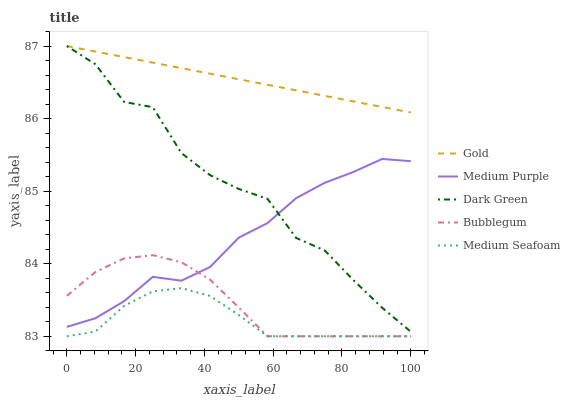Does Medium Seafoam have the minimum area under the curve?
Answer yes or no. Yes. Does Gold have the maximum area under the curve?
Answer yes or no. Yes. Does Bubblegum have the minimum area under the curve?
Answer yes or no. No. Does Bubblegum have the maximum area under the curve?
Answer yes or no. No. Is Gold the smoothest?
Answer yes or no. Yes. Is Dark Green the roughest?
Answer yes or no. Yes. Is Medium Seafoam the smoothest?
Answer yes or no. No. Is Medium Seafoam the roughest?
Answer yes or no. No. Does Medium Seafoam have the lowest value?
Answer yes or no. Yes. Does Gold have the lowest value?
Answer yes or no. No. Does Dark Green have the highest value?
Answer yes or no. Yes. Does Bubblegum have the highest value?
Answer yes or no. No. Is Medium Seafoam less than Medium Purple?
Answer yes or no. Yes. Is Gold greater than Medium Seafoam?
Answer yes or no. Yes. Does Medium Seafoam intersect Bubblegum?
Answer yes or no. Yes. Is Medium Seafoam less than Bubblegum?
Answer yes or no. No. Is Medium Seafoam greater than Bubblegum?
Answer yes or no. No. Does Medium Seafoam intersect Medium Purple?
Answer yes or no. No. 